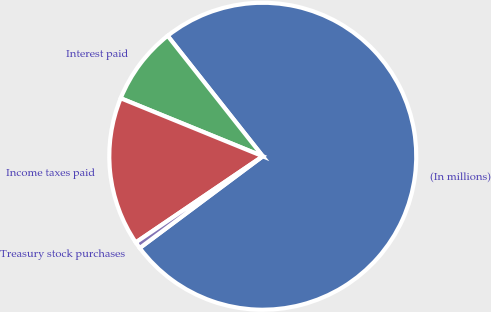Convert chart to OTSL. <chart><loc_0><loc_0><loc_500><loc_500><pie_chart><fcel>(In millions)<fcel>Interest paid<fcel>Income taxes paid<fcel>Treasury stock purchases<nl><fcel>75.44%<fcel>8.19%<fcel>15.66%<fcel>0.71%<nl></chart> 